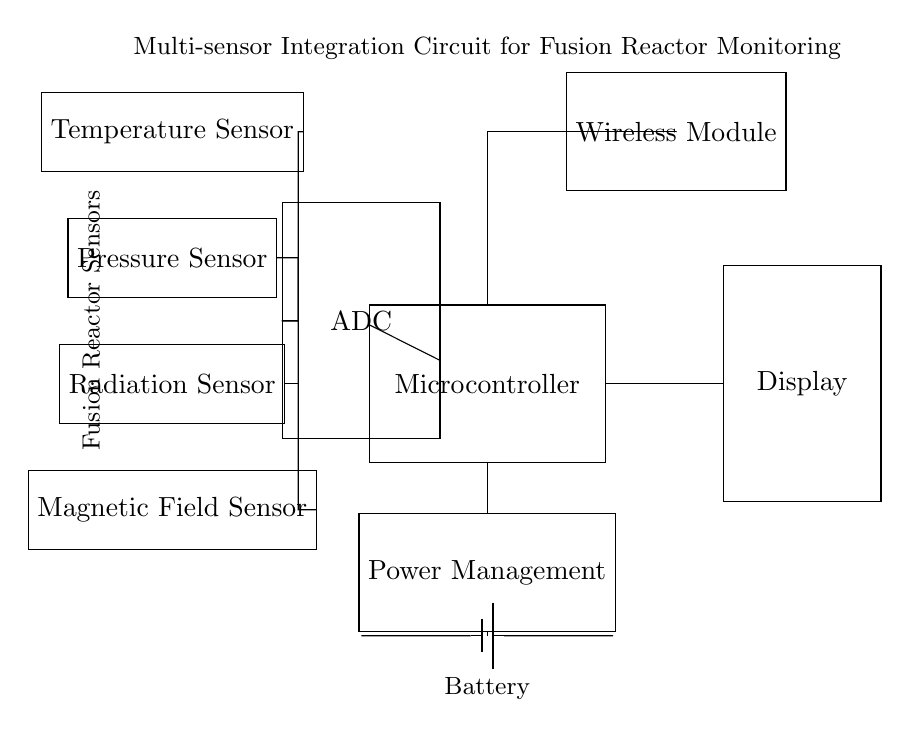What is the main component of this circuit? The main component present in this circuit diagram is the microcontroller, identified as the central processing unit responsible for managing the signals from the sensors.
Answer: Microcontroller How many sensors are connected to the ADC? The ADC receives input from four distinct sensors: temperature, pressure, radiation, and magnetic field sensors, as seen from the connections leading to the ADC in the diagram.
Answer: Four Where does the power to the circuit originate? The power is supplied by a battery located at the bottom of the circuit, which provides necessary voltage to the entire system; the connection from the battery to the power management indicates the source.
Answer: Battery What type of data does the wireless module transmit? The wireless module is designed to transmit the processed data from the microcontroller, which consists of the parameters gathered from the integrated sensors, enabling remote monitoring.
Answer: Sensor data Which component manages the power supply? The power management component ensures efficient distribution and regulation of power from the battery to the microcontroller and other parts of the circuit, indicated by its connection to multiple elements.
Answer: Power Management What is the role of the ADC in this circuit? The ADC, or Analog to Digital Converter, is crucial as it transforms the analog signals from each of the sensors into digital data that the microcontroller can process, allowing for accurate monitoring and control.
Answer: Conversion of signals What information will be displayed? The display will present the processed data from the microcontroller, which comes from the readings of the temperature, pressure, radiation, and magnetic field sensors, allowing users to observe current reactor conditions.
Answer: Reactor parameters 